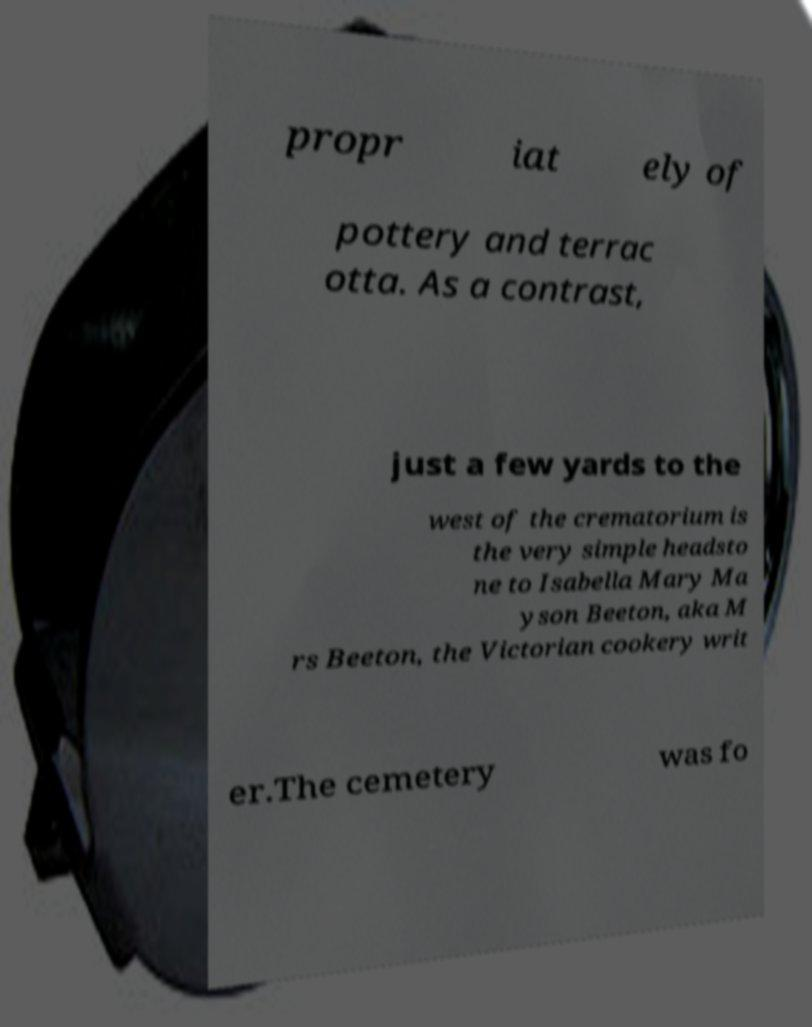There's text embedded in this image that I need extracted. Can you transcribe it verbatim? propr iat ely of pottery and terrac otta. As a contrast, just a few yards to the west of the crematorium is the very simple headsto ne to Isabella Mary Ma yson Beeton, aka M rs Beeton, the Victorian cookery writ er.The cemetery was fo 